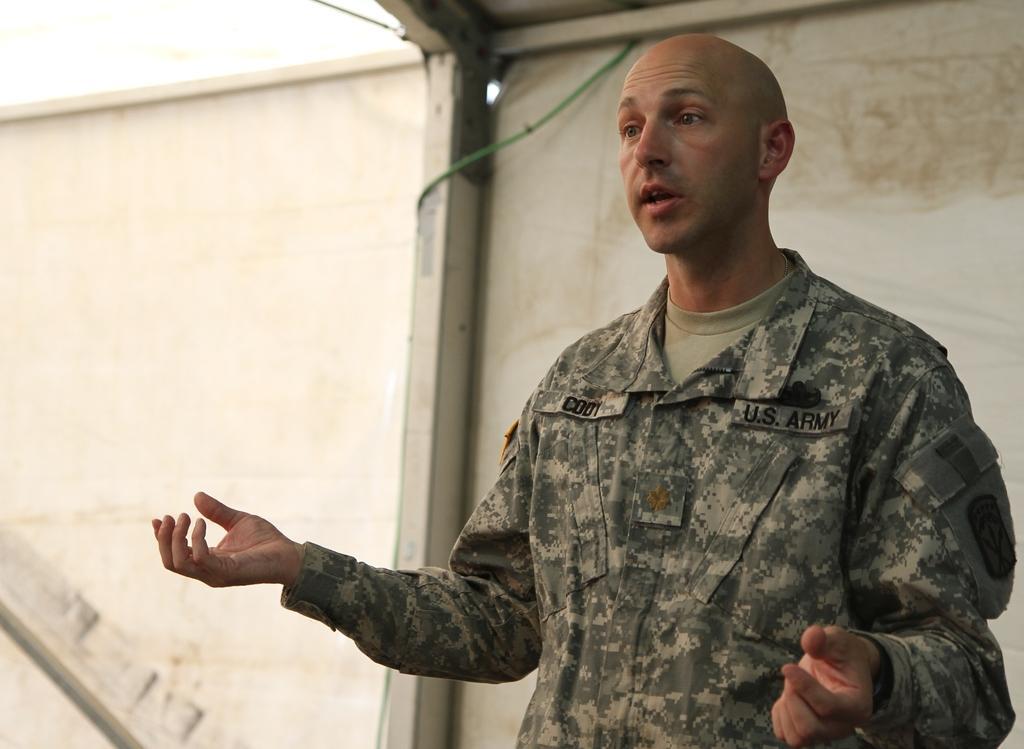Please provide a concise description of this image. In this image we can see a person wearing camouflage dress standing and in the background of the image there is white color sheet. 